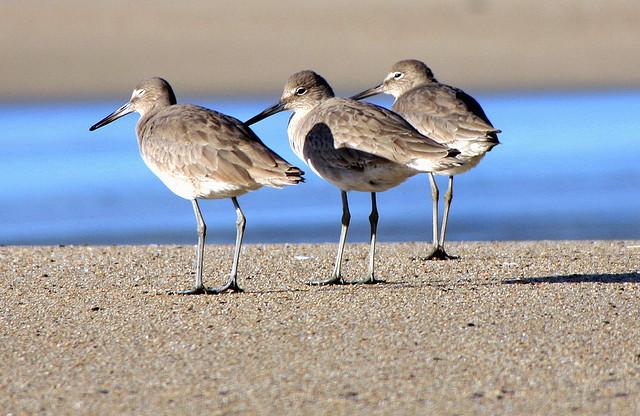What are the birds standing on?
Give a very brief answer. Sand. Are shadows cast?
Be succinct. Yes. What kind of birds are these?
Concise answer only. Seagulls. 